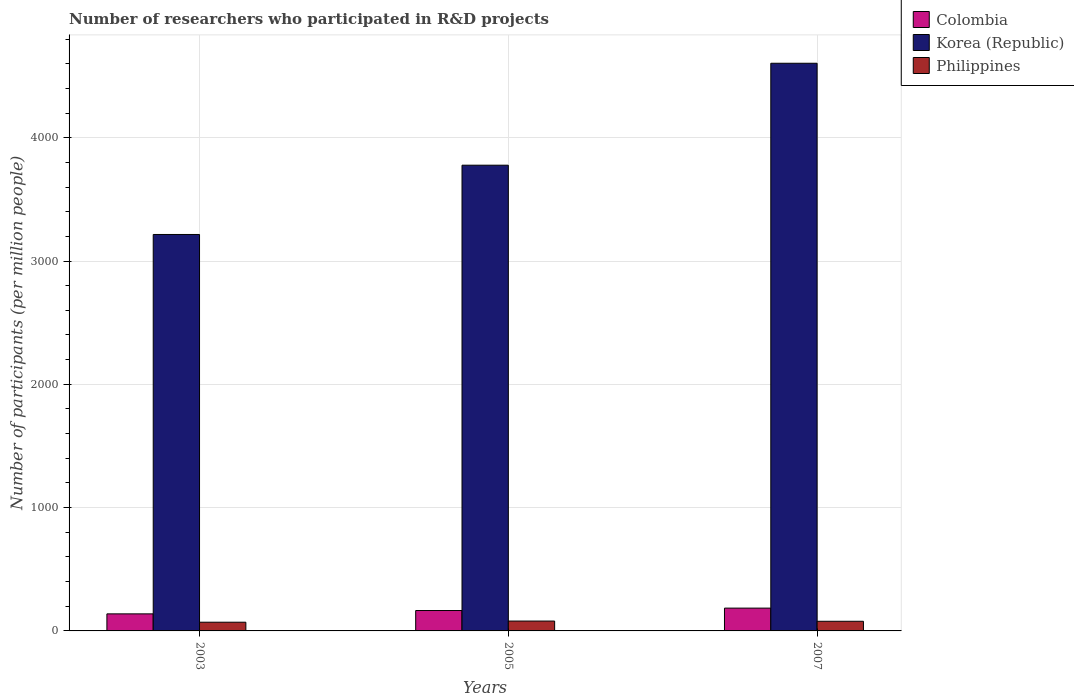How many groups of bars are there?
Offer a terse response. 3. Are the number of bars per tick equal to the number of legend labels?
Ensure brevity in your answer.  Yes. How many bars are there on the 3rd tick from the right?
Provide a short and direct response. 3. In how many cases, is the number of bars for a given year not equal to the number of legend labels?
Your answer should be compact. 0. What is the number of researchers who participated in R&D projects in Korea (Republic) in 2003?
Make the answer very short. 3215.21. Across all years, what is the maximum number of researchers who participated in R&D projects in Korea (Republic)?
Keep it short and to the point. 4603.84. Across all years, what is the minimum number of researchers who participated in R&D projects in Colombia?
Ensure brevity in your answer.  138.35. In which year was the number of researchers who participated in R&D projects in Colombia maximum?
Provide a succinct answer. 2007. What is the total number of researchers who participated in R&D projects in Colombia in the graph?
Provide a succinct answer. 488.82. What is the difference between the number of researchers who participated in R&D projects in Colombia in 2003 and that in 2007?
Ensure brevity in your answer.  -46.65. What is the difference between the number of researchers who participated in R&D projects in Philippines in 2003 and the number of researchers who participated in R&D projects in Colombia in 2005?
Ensure brevity in your answer.  -94.85. What is the average number of researchers who participated in R&D projects in Philippines per year?
Make the answer very short. 76.29. In the year 2003, what is the difference between the number of researchers who participated in R&D projects in Colombia and number of researchers who participated in R&D projects in Korea (Republic)?
Give a very brief answer. -3076.86. In how many years, is the number of researchers who participated in R&D projects in Colombia greater than 3000?
Offer a very short reply. 0. What is the ratio of the number of researchers who participated in R&D projects in Philippines in 2005 to that in 2007?
Make the answer very short. 1.02. Is the number of researchers who participated in R&D projects in Colombia in 2003 less than that in 2007?
Your answer should be very brief. Yes. What is the difference between the highest and the second highest number of researchers who participated in R&D projects in Korea (Republic)?
Give a very brief answer. 826.73. What is the difference between the highest and the lowest number of researchers who participated in R&D projects in Korea (Republic)?
Offer a terse response. 1388.63. Is the sum of the number of researchers who participated in R&D projects in Korea (Republic) in 2005 and 2007 greater than the maximum number of researchers who participated in R&D projects in Colombia across all years?
Offer a very short reply. Yes. What does the 2nd bar from the left in 2005 represents?
Make the answer very short. Korea (Republic). What does the 2nd bar from the right in 2005 represents?
Offer a very short reply. Korea (Republic). How many years are there in the graph?
Offer a terse response. 3. What is the difference between two consecutive major ticks on the Y-axis?
Make the answer very short. 1000. Are the values on the major ticks of Y-axis written in scientific E-notation?
Provide a succinct answer. No. Does the graph contain any zero values?
Offer a very short reply. No. Does the graph contain grids?
Keep it short and to the point. Yes. How many legend labels are there?
Make the answer very short. 3. How are the legend labels stacked?
Your response must be concise. Vertical. What is the title of the graph?
Your answer should be very brief. Number of researchers who participated in R&D projects. Does "Least developed countries" appear as one of the legend labels in the graph?
Give a very brief answer. No. What is the label or title of the X-axis?
Ensure brevity in your answer.  Years. What is the label or title of the Y-axis?
Give a very brief answer. Number of participants (per million people). What is the Number of participants (per million people) of Colombia in 2003?
Your answer should be very brief. 138.35. What is the Number of participants (per million people) in Korea (Republic) in 2003?
Offer a very short reply. 3215.21. What is the Number of participants (per million people) of Philippines in 2003?
Your answer should be compact. 70.63. What is the Number of participants (per million people) of Colombia in 2005?
Make the answer very short. 165.47. What is the Number of participants (per million people) of Korea (Republic) in 2005?
Your answer should be compact. 3777.11. What is the Number of participants (per million people) in Philippines in 2005?
Offer a terse response. 80.05. What is the Number of participants (per million people) of Colombia in 2007?
Give a very brief answer. 185. What is the Number of participants (per million people) of Korea (Republic) in 2007?
Offer a very short reply. 4603.84. What is the Number of participants (per million people) in Philippines in 2007?
Your answer should be very brief. 78.2. Across all years, what is the maximum Number of participants (per million people) of Colombia?
Ensure brevity in your answer.  185. Across all years, what is the maximum Number of participants (per million people) in Korea (Republic)?
Provide a short and direct response. 4603.84. Across all years, what is the maximum Number of participants (per million people) in Philippines?
Offer a very short reply. 80.05. Across all years, what is the minimum Number of participants (per million people) in Colombia?
Offer a very short reply. 138.35. Across all years, what is the minimum Number of participants (per million people) in Korea (Republic)?
Offer a terse response. 3215.21. Across all years, what is the minimum Number of participants (per million people) in Philippines?
Offer a very short reply. 70.63. What is the total Number of participants (per million people) of Colombia in the graph?
Your response must be concise. 488.82. What is the total Number of participants (per million people) in Korea (Republic) in the graph?
Offer a very short reply. 1.16e+04. What is the total Number of participants (per million people) of Philippines in the graph?
Your answer should be compact. 228.88. What is the difference between the Number of participants (per million people) of Colombia in 2003 and that in 2005?
Ensure brevity in your answer.  -27.13. What is the difference between the Number of participants (per million people) in Korea (Republic) in 2003 and that in 2005?
Provide a short and direct response. -561.9. What is the difference between the Number of participants (per million people) of Philippines in 2003 and that in 2005?
Provide a succinct answer. -9.43. What is the difference between the Number of participants (per million people) of Colombia in 2003 and that in 2007?
Your answer should be very brief. -46.65. What is the difference between the Number of participants (per million people) of Korea (Republic) in 2003 and that in 2007?
Make the answer very short. -1388.63. What is the difference between the Number of participants (per million people) of Philippines in 2003 and that in 2007?
Make the answer very short. -7.57. What is the difference between the Number of participants (per million people) in Colombia in 2005 and that in 2007?
Your answer should be very brief. -19.52. What is the difference between the Number of participants (per million people) of Korea (Republic) in 2005 and that in 2007?
Provide a short and direct response. -826.73. What is the difference between the Number of participants (per million people) in Philippines in 2005 and that in 2007?
Your answer should be compact. 1.86. What is the difference between the Number of participants (per million people) of Colombia in 2003 and the Number of participants (per million people) of Korea (Republic) in 2005?
Your answer should be compact. -3638.76. What is the difference between the Number of participants (per million people) of Colombia in 2003 and the Number of participants (per million people) of Philippines in 2005?
Provide a short and direct response. 58.29. What is the difference between the Number of participants (per million people) of Korea (Republic) in 2003 and the Number of participants (per million people) of Philippines in 2005?
Your answer should be compact. 3135.16. What is the difference between the Number of participants (per million people) in Colombia in 2003 and the Number of participants (per million people) in Korea (Republic) in 2007?
Your response must be concise. -4465.49. What is the difference between the Number of participants (per million people) in Colombia in 2003 and the Number of participants (per million people) in Philippines in 2007?
Provide a short and direct response. 60.15. What is the difference between the Number of participants (per million people) of Korea (Republic) in 2003 and the Number of participants (per million people) of Philippines in 2007?
Your response must be concise. 3137.01. What is the difference between the Number of participants (per million people) in Colombia in 2005 and the Number of participants (per million people) in Korea (Republic) in 2007?
Make the answer very short. -4438.36. What is the difference between the Number of participants (per million people) in Colombia in 2005 and the Number of participants (per million people) in Philippines in 2007?
Offer a terse response. 87.27. What is the difference between the Number of participants (per million people) of Korea (Republic) in 2005 and the Number of participants (per million people) of Philippines in 2007?
Give a very brief answer. 3698.91. What is the average Number of participants (per million people) in Colombia per year?
Provide a succinct answer. 162.94. What is the average Number of participants (per million people) in Korea (Republic) per year?
Your answer should be compact. 3865.39. What is the average Number of participants (per million people) of Philippines per year?
Ensure brevity in your answer.  76.29. In the year 2003, what is the difference between the Number of participants (per million people) in Colombia and Number of participants (per million people) in Korea (Republic)?
Your answer should be compact. -3076.86. In the year 2003, what is the difference between the Number of participants (per million people) of Colombia and Number of participants (per million people) of Philippines?
Make the answer very short. 67.72. In the year 2003, what is the difference between the Number of participants (per million people) of Korea (Republic) and Number of participants (per million people) of Philippines?
Keep it short and to the point. 3144.59. In the year 2005, what is the difference between the Number of participants (per million people) of Colombia and Number of participants (per million people) of Korea (Republic)?
Offer a terse response. -3611.63. In the year 2005, what is the difference between the Number of participants (per million people) in Colombia and Number of participants (per million people) in Philippines?
Your response must be concise. 85.42. In the year 2005, what is the difference between the Number of participants (per million people) in Korea (Republic) and Number of participants (per million people) in Philippines?
Offer a terse response. 3697.05. In the year 2007, what is the difference between the Number of participants (per million people) in Colombia and Number of participants (per million people) in Korea (Republic)?
Provide a succinct answer. -4418.84. In the year 2007, what is the difference between the Number of participants (per million people) in Colombia and Number of participants (per million people) in Philippines?
Ensure brevity in your answer.  106.8. In the year 2007, what is the difference between the Number of participants (per million people) of Korea (Republic) and Number of participants (per million people) of Philippines?
Your answer should be compact. 4525.64. What is the ratio of the Number of participants (per million people) of Colombia in 2003 to that in 2005?
Keep it short and to the point. 0.84. What is the ratio of the Number of participants (per million people) in Korea (Republic) in 2003 to that in 2005?
Provide a succinct answer. 0.85. What is the ratio of the Number of participants (per million people) of Philippines in 2003 to that in 2005?
Make the answer very short. 0.88. What is the ratio of the Number of participants (per million people) in Colombia in 2003 to that in 2007?
Provide a succinct answer. 0.75. What is the ratio of the Number of participants (per million people) of Korea (Republic) in 2003 to that in 2007?
Keep it short and to the point. 0.7. What is the ratio of the Number of participants (per million people) in Philippines in 2003 to that in 2007?
Give a very brief answer. 0.9. What is the ratio of the Number of participants (per million people) of Colombia in 2005 to that in 2007?
Offer a very short reply. 0.89. What is the ratio of the Number of participants (per million people) in Korea (Republic) in 2005 to that in 2007?
Your answer should be very brief. 0.82. What is the ratio of the Number of participants (per million people) of Philippines in 2005 to that in 2007?
Provide a succinct answer. 1.02. What is the difference between the highest and the second highest Number of participants (per million people) in Colombia?
Offer a terse response. 19.52. What is the difference between the highest and the second highest Number of participants (per million people) of Korea (Republic)?
Offer a very short reply. 826.73. What is the difference between the highest and the second highest Number of participants (per million people) in Philippines?
Provide a succinct answer. 1.86. What is the difference between the highest and the lowest Number of participants (per million people) in Colombia?
Make the answer very short. 46.65. What is the difference between the highest and the lowest Number of participants (per million people) in Korea (Republic)?
Provide a short and direct response. 1388.63. What is the difference between the highest and the lowest Number of participants (per million people) of Philippines?
Offer a terse response. 9.43. 